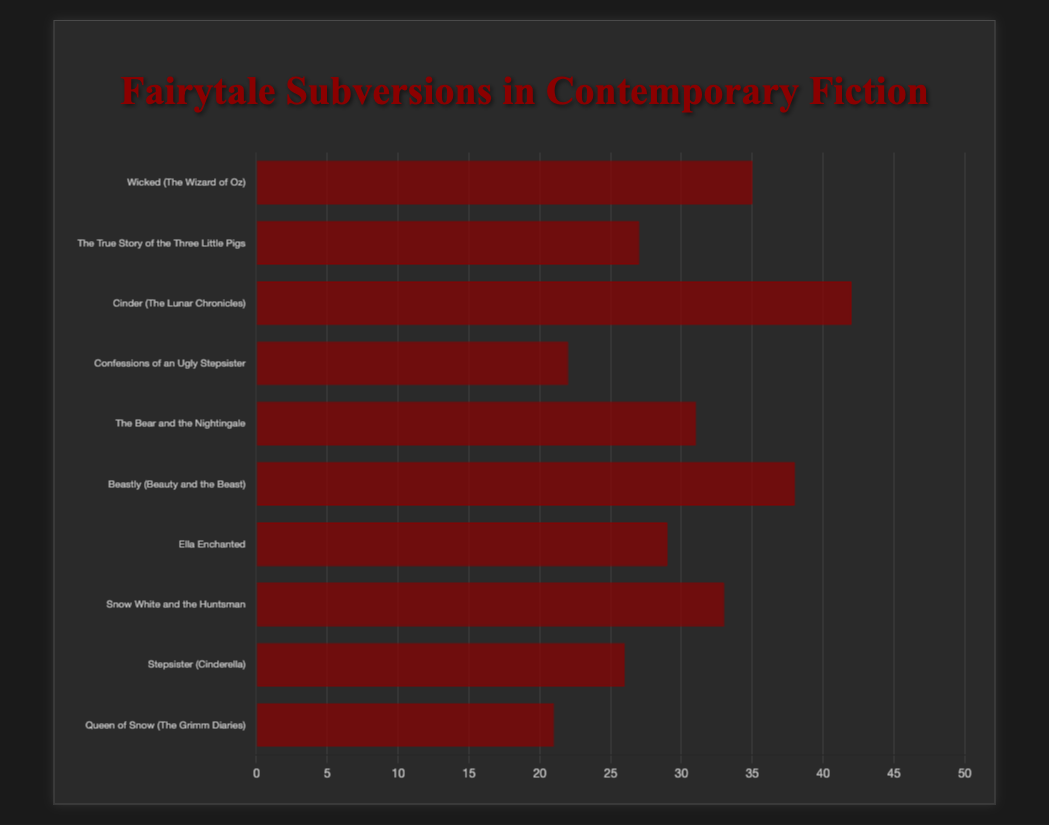What is the most common subversion type according to the chart? To determine the most common subversion type, look for the bar with the greatest length on the horizontal bar chart. The chart shows that "Cinder (The Lunar Chronicles)" has 42 counts.
Answer: Sci-Fi Retelling Which subversion type has more entries: "Villain Perspective" or "Alternative View"? Compare the lengths of the bars associated with these subversion types. "Wicked (The Wizard of Oz)" (Villain Perspective) has 35 counts, whereas "The True Story of the Three Little Pigs" (Alternative View) has 27 counts.
Answer: Villain Perspective What is the total count of entries for "Modern Retelling" and "Dark Fantasy"? Add the counts of "Beastly (Beauty and the Beast)" (Modern Retelling) and "Snow White and the Huntsman" (Dark Fantasy): 38 (Modern Retelling) + 33 (Dark Fantasy) = 71.
Answer: 71 Which subversion type has the least entries? Find the shortest bar in the chart. "Queen of Snow (The Grimm Diaries)" has the lowest count with 21.
Answer: Multi-perspective How many more entries does "Historical Fiction" have compared to "Feminist Interpretation"? Subtract the count of "Stepsister (Cinderella)" (Feminist Interpretation) from "Confessions of an Ugly Stepsister" (Historical Fiction): 22 (Historical Fiction) - 26 (Feminist Interpretation) = -4. This indicates that "Historical Fiction" has 4 fewer entries compared to "Feminist Interpretation".
Answer: -4 Comparing "Alternative World" and "Russian Folktale," which has fewer entries? Compare the counts of "Ella Enchanted" (Alternative World) and "The Bear and the Nightingale" (Russian Folktale): 29 (Alternative World) versus 31 (Russian Folktale).
Answer: Alternative World What is the average count of entries for the subversion types represented in the chart? Calculate the average by summing all counts and dividing by the number of types: (35 + 27 + 42 + 22 + 31 + 38 + 29 + 33 + 26 + 21) / 10 = 30.4.
Answer: 30.4 How much higher is the count of the "Sci-Fi Retelling" type compared to the "Historical Fiction" type? Subtract the count of "Confessions of an Ugly Stepsister" (Historical Fiction) from "Cinder (The Lunar Chronicles)" (Sci-Fi Retelling): 42 - 22 = 20.
Answer: 20 What is the combined count for the subversion types that have the word "Cinderella" in their titles? Add the counts of "Cinder (The Lunar Chronicles)" and "Stepsister (Cinderella)": 42 + 26 = 68.
Answer: 68 List the titles of the subversion types that have more than 30 entries. Identify bars with counts greater than 30. The titles are "Wicked (The Wizard of Oz)", "Cinder (The Lunar Chronicles)", "The Bear and the Nightingale", "Beastly (Beauty and the Beast)", and "Snow White and the Huntsman".
Answer: Wicked (The Wizard of Oz), Cinder (The Lunar Chronicles), The Bear and the Nightingale, Beastly (Beauty and the Beast), Snow White and the Huntsman 